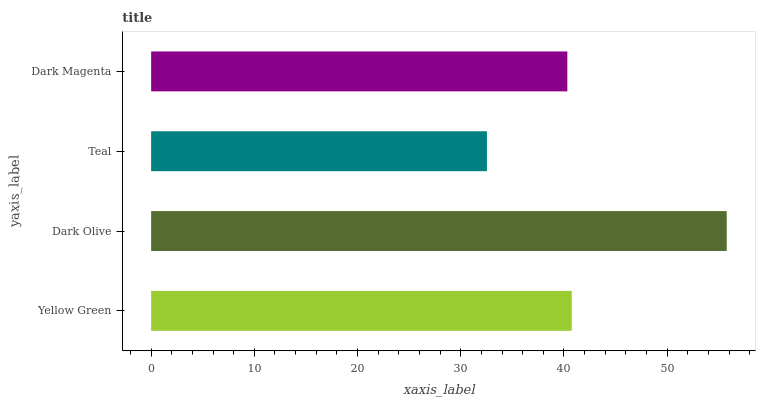Is Teal the minimum?
Answer yes or no. Yes. Is Dark Olive the maximum?
Answer yes or no. Yes. Is Dark Olive the minimum?
Answer yes or no. No. Is Teal the maximum?
Answer yes or no. No. Is Dark Olive greater than Teal?
Answer yes or no. Yes. Is Teal less than Dark Olive?
Answer yes or no. Yes. Is Teal greater than Dark Olive?
Answer yes or no. No. Is Dark Olive less than Teal?
Answer yes or no. No. Is Yellow Green the high median?
Answer yes or no. Yes. Is Dark Magenta the low median?
Answer yes or no. Yes. Is Dark Olive the high median?
Answer yes or no. No. Is Dark Olive the low median?
Answer yes or no. No. 